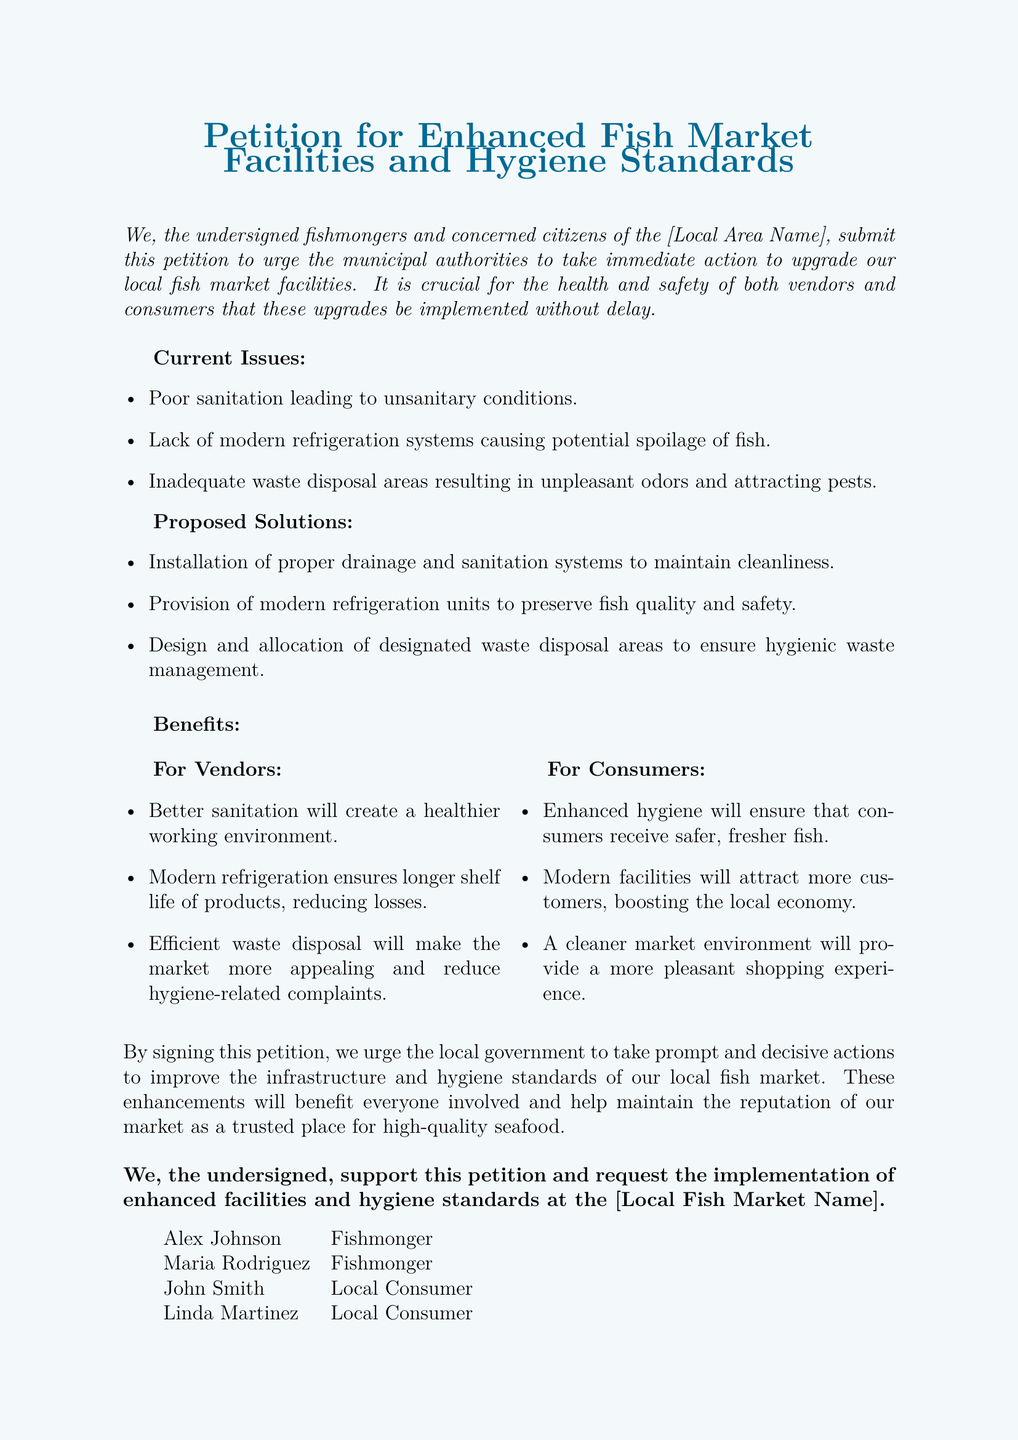what is the title of the petition? The title of the petition is prominently displayed at the top of the document, which is "Petition for Enhanced Fish Market Facilities and Hygiene Standards."
Answer: Petition for Enhanced Fish Market Facilities and Hygiene Standards how many local consumers signed the petition? The document lists two individuals identified as local consumers who signed the petition.
Answer: 2 what is one current issue mentioned in the petition? The petition outlines several current issues, one of which is poor sanitation leading to unsanitary conditions.
Answer: Poor sanitation what is one proposed solution in the petition? The petition proposes several solutions, including the installation of proper drainage and sanitation systems to maintain cleanliness.
Answer: Installation of proper drainage and sanitation systems who is one of the fishmongers listed in the petition? The document includes a list of individuals, identifying Alex Johnson as one of the fishmongers who signed the petition.
Answer: Alex Johnson what benefit does better sanitation provide for vendors? The document states that better sanitation will create a healthier working environment for vendors.
Answer: A healthier working environment what are dedicated waste disposal areas aimed to ensure? The petition states that the design and allocation of dedicated waste disposal areas aim to ensure hygienic waste management.
Answer: Hygienic waste management which color is used for the title of the petition? The title of the petition is displayed in the color seablue.
Answer: Seablue 